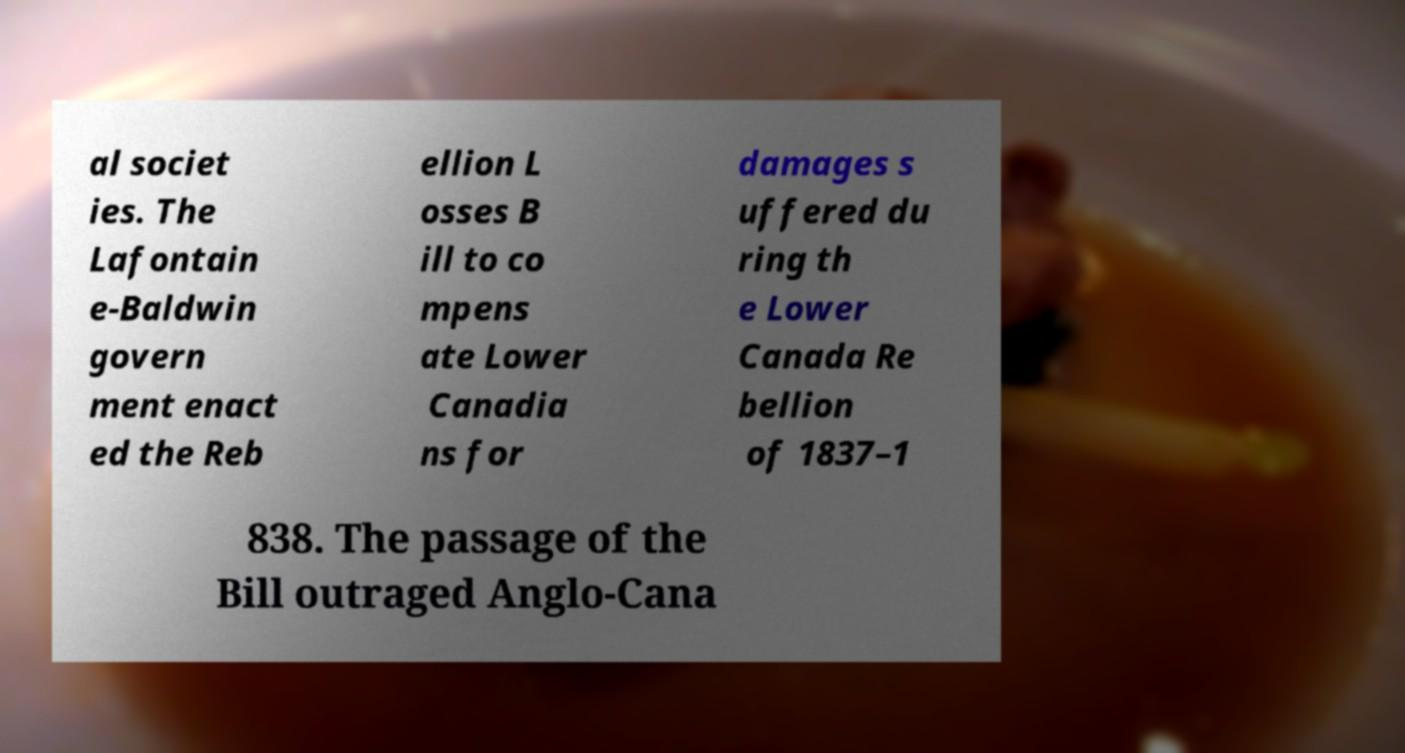Please identify and transcribe the text found in this image. al societ ies. The Lafontain e-Baldwin govern ment enact ed the Reb ellion L osses B ill to co mpens ate Lower Canadia ns for damages s uffered du ring th e Lower Canada Re bellion of 1837–1 838. The passage of the Bill outraged Anglo-Cana 